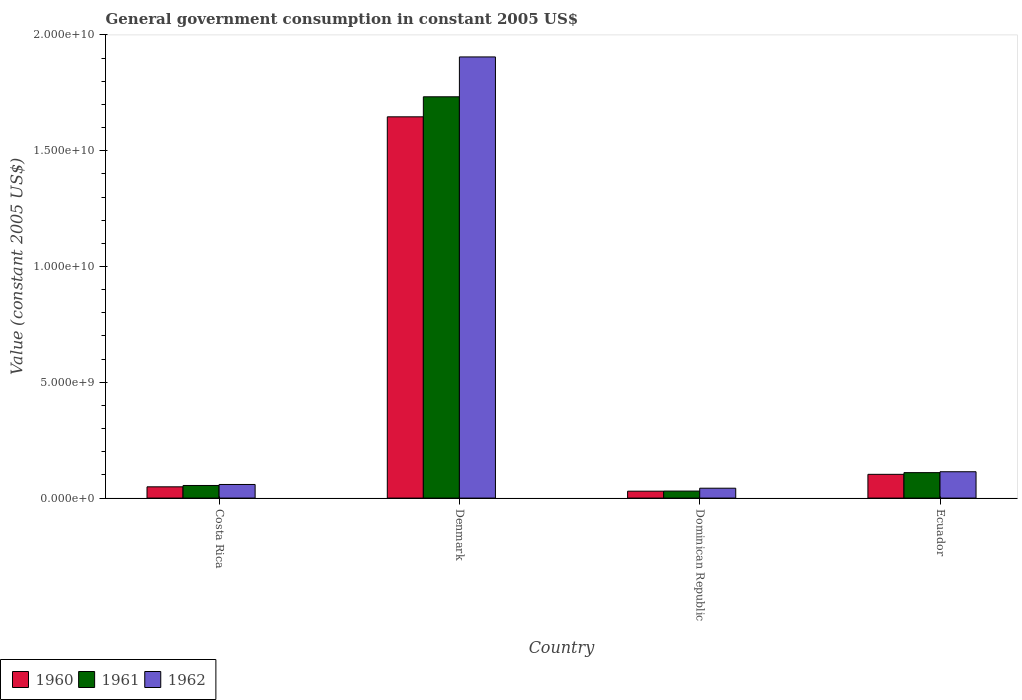How many groups of bars are there?
Offer a terse response. 4. Are the number of bars per tick equal to the number of legend labels?
Your response must be concise. Yes. How many bars are there on the 1st tick from the right?
Offer a very short reply. 3. What is the government conusmption in 1962 in Dominican Republic?
Your answer should be compact. 4.27e+08. Across all countries, what is the maximum government conusmption in 1961?
Provide a short and direct response. 1.73e+1. Across all countries, what is the minimum government conusmption in 1961?
Keep it short and to the point. 3.03e+08. In which country was the government conusmption in 1962 minimum?
Keep it short and to the point. Dominican Republic. What is the total government conusmption in 1960 in the graph?
Your answer should be compact. 1.83e+1. What is the difference between the government conusmption in 1962 in Costa Rica and that in Ecuador?
Your response must be concise. -5.50e+08. What is the difference between the government conusmption in 1961 in Costa Rica and the government conusmption in 1962 in Dominican Republic?
Provide a succinct answer. 1.18e+08. What is the average government conusmption in 1960 per country?
Keep it short and to the point. 4.57e+09. What is the difference between the government conusmption of/in 1960 and government conusmption of/in 1961 in Costa Rica?
Provide a succinct answer. -5.79e+07. What is the ratio of the government conusmption in 1962 in Denmark to that in Ecuador?
Your answer should be compact. 16.74. Is the difference between the government conusmption in 1960 in Dominican Republic and Ecuador greater than the difference between the government conusmption in 1961 in Dominican Republic and Ecuador?
Ensure brevity in your answer.  Yes. What is the difference between the highest and the second highest government conusmption in 1962?
Ensure brevity in your answer.  -5.50e+08. What is the difference between the highest and the lowest government conusmption in 1960?
Ensure brevity in your answer.  1.62e+1. Is the sum of the government conusmption in 1961 in Costa Rica and Dominican Republic greater than the maximum government conusmption in 1962 across all countries?
Offer a very short reply. No. What does the 3rd bar from the left in Ecuador represents?
Provide a short and direct response. 1962. Is it the case that in every country, the sum of the government conusmption in 1962 and government conusmption in 1961 is greater than the government conusmption in 1960?
Ensure brevity in your answer.  Yes. Are all the bars in the graph horizontal?
Your response must be concise. No. Where does the legend appear in the graph?
Offer a terse response. Bottom left. How many legend labels are there?
Your response must be concise. 3. What is the title of the graph?
Provide a succinct answer. General government consumption in constant 2005 US$. Does "1972" appear as one of the legend labels in the graph?
Give a very brief answer. No. What is the label or title of the Y-axis?
Offer a terse response. Value (constant 2005 US$). What is the Value (constant 2005 US$) in 1960 in Costa Rica?
Your response must be concise. 4.87e+08. What is the Value (constant 2005 US$) of 1961 in Costa Rica?
Your answer should be compact. 5.45e+08. What is the Value (constant 2005 US$) of 1962 in Costa Rica?
Offer a terse response. 5.88e+08. What is the Value (constant 2005 US$) in 1960 in Denmark?
Your answer should be compact. 1.65e+1. What is the Value (constant 2005 US$) of 1961 in Denmark?
Your response must be concise. 1.73e+1. What is the Value (constant 2005 US$) in 1962 in Denmark?
Give a very brief answer. 1.91e+1. What is the Value (constant 2005 US$) in 1960 in Dominican Republic?
Give a very brief answer. 2.99e+08. What is the Value (constant 2005 US$) in 1961 in Dominican Republic?
Offer a terse response. 3.03e+08. What is the Value (constant 2005 US$) in 1962 in Dominican Republic?
Offer a very short reply. 4.27e+08. What is the Value (constant 2005 US$) of 1960 in Ecuador?
Ensure brevity in your answer.  1.03e+09. What is the Value (constant 2005 US$) of 1961 in Ecuador?
Give a very brief answer. 1.10e+09. What is the Value (constant 2005 US$) of 1962 in Ecuador?
Give a very brief answer. 1.14e+09. Across all countries, what is the maximum Value (constant 2005 US$) in 1960?
Ensure brevity in your answer.  1.65e+1. Across all countries, what is the maximum Value (constant 2005 US$) in 1961?
Give a very brief answer. 1.73e+1. Across all countries, what is the maximum Value (constant 2005 US$) of 1962?
Ensure brevity in your answer.  1.91e+1. Across all countries, what is the minimum Value (constant 2005 US$) of 1960?
Offer a very short reply. 2.99e+08. Across all countries, what is the minimum Value (constant 2005 US$) in 1961?
Ensure brevity in your answer.  3.03e+08. Across all countries, what is the minimum Value (constant 2005 US$) in 1962?
Your answer should be compact. 4.27e+08. What is the total Value (constant 2005 US$) of 1960 in the graph?
Offer a terse response. 1.83e+1. What is the total Value (constant 2005 US$) in 1961 in the graph?
Your answer should be compact. 1.93e+1. What is the total Value (constant 2005 US$) in 1962 in the graph?
Your answer should be compact. 2.12e+1. What is the difference between the Value (constant 2005 US$) in 1960 in Costa Rica and that in Denmark?
Provide a succinct answer. -1.60e+1. What is the difference between the Value (constant 2005 US$) in 1961 in Costa Rica and that in Denmark?
Your answer should be very brief. -1.68e+1. What is the difference between the Value (constant 2005 US$) of 1962 in Costa Rica and that in Denmark?
Make the answer very short. -1.85e+1. What is the difference between the Value (constant 2005 US$) in 1960 in Costa Rica and that in Dominican Republic?
Provide a succinct answer. 1.88e+08. What is the difference between the Value (constant 2005 US$) in 1961 in Costa Rica and that in Dominican Republic?
Ensure brevity in your answer.  2.41e+08. What is the difference between the Value (constant 2005 US$) in 1962 in Costa Rica and that in Dominican Republic?
Your answer should be compact. 1.61e+08. What is the difference between the Value (constant 2005 US$) in 1960 in Costa Rica and that in Ecuador?
Provide a succinct answer. -5.39e+08. What is the difference between the Value (constant 2005 US$) in 1961 in Costa Rica and that in Ecuador?
Offer a terse response. -5.55e+08. What is the difference between the Value (constant 2005 US$) in 1962 in Costa Rica and that in Ecuador?
Your answer should be compact. -5.50e+08. What is the difference between the Value (constant 2005 US$) in 1960 in Denmark and that in Dominican Republic?
Provide a short and direct response. 1.62e+1. What is the difference between the Value (constant 2005 US$) in 1961 in Denmark and that in Dominican Republic?
Make the answer very short. 1.70e+1. What is the difference between the Value (constant 2005 US$) in 1962 in Denmark and that in Dominican Republic?
Keep it short and to the point. 1.86e+1. What is the difference between the Value (constant 2005 US$) in 1960 in Denmark and that in Ecuador?
Give a very brief answer. 1.54e+1. What is the difference between the Value (constant 2005 US$) in 1961 in Denmark and that in Ecuador?
Offer a terse response. 1.62e+1. What is the difference between the Value (constant 2005 US$) in 1962 in Denmark and that in Ecuador?
Provide a succinct answer. 1.79e+1. What is the difference between the Value (constant 2005 US$) of 1960 in Dominican Republic and that in Ecuador?
Make the answer very short. -7.27e+08. What is the difference between the Value (constant 2005 US$) of 1961 in Dominican Republic and that in Ecuador?
Offer a very short reply. -7.96e+08. What is the difference between the Value (constant 2005 US$) of 1962 in Dominican Republic and that in Ecuador?
Keep it short and to the point. -7.11e+08. What is the difference between the Value (constant 2005 US$) of 1960 in Costa Rica and the Value (constant 2005 US$) of 1961 in Denmark?
Make the answer very short. -1.68e+1. What is the difference between the Value (constant 2005 US$) of 1960 in Costa Rica and the Value (constant 2005 US$) of 1962 in Denmark?
Provide a succinct answer. -1.86e+1. What is the difference between the Value (constant 2005 US$) in 1961 in Costa Rica and the Value (constant 2005 US$) in 1962 in Denmark?
Keep it short and to the point. -1.85e+1. What is the difference between the Value (constant 2005 US$) of 1960 in Costa Rica and the Value (constant 2005 US$) of 1961 in Dominican Republic?
Provide a short and direct response. 1.83e+08. What is the difference between the Value (constant 2005 US$) of 1960 in Costa Rica and the Value (constant 2005 US$) of 1962 in Dominican Republic?
Your response must be concise. 6.01e+07. What is the difference between the Value (constant 2005 US$) in 1961 in Costa Rica and the Value (constant 2005 US$) in 1962 in Dominican Republic?
Provide a short and direct response. 1.18e+08. What is the difference between the Value (constant 2005 US$) in 1960 in Costa Rica and the Value (constant 2005 US$) in 1961 in Ecuador?
Offer a terse response. -6.13e+08. What is the difference between the Value (constant 2005 US$) of 1960 in Costa Rica and the Value (constant 2005 US$) of 1962 in Ecuador?
Your answer should be compact. -6.51e+08. What is the difference between the Value (constant 2005 US$) of 1961 in Costa Rica and the Value (constant 2005 US$) of 1962 in Ecuador?
Keep it short and to the point. -5.93e+08. What is the difference between the Value (constant 2005 US$) in 1960 in Denmark and the Value (constant 2005 US$) in 1961 in Dominican Republic?
Make the answer very short. 1.62e+1. What is the difference between the Value (constant 2005 US$) in 1960 in Denmark and the Value (constant 2005 US$) in 1962 in Dominican Republic?
Keep it short and to the point. 1.60e+1. What is the difference between the Value (constant 2005 US$) in 1961 in Denmark and the Value (constant 2005 US$) in 1962 in Dominican Republic?
Your answer should be compact. 1.69e+1. What is the difference between the Value (constant 2005 US$) in 1960 in Denmark and the Value (constant 2005 US$) in 1961 in Ecuador?
Keep it short and to the point. 1.54e+1. What is the difference between the Value (constant 2005 US$) of 1960 in Denmark and the Value (constant 2005 US$) of 1962 in Ecuador?
Ensure brevity in your answer.  1.53e+1. What is the difference between the Value (constant 2005 US$) of 1961 in Denmark and the Value (constant 2005 US$) of 1962 in Ecuador?
Provide a short and direct response. 1.62e+1. What is the difference between the Value (constant 2005 US$) in 1960 in Dominican Republic and the Value (constant 2005 US$) in 1961 in Ecuador?
Keep it short and to the point. -8.01e+08. What is the difference between the Value (constant 2005 US$) of 1960 in Dominican Republic and the Value (constant 2005 US$) of 1962 in Ecuador?
Offer a very short reply. -8.39e+08. What is the difference between the Value (constant 2005 US$) in 1961 in Dominican Republic and the Value (constant 2005 US$) in 1962 in Ecuador?
Offer a very short reply. -8.35e+08. What is the average Value (constant 2005 US$) in 1960 per country?
Provide a short and direct response. 4.57e+09. What is the average Value (constant 2005 US$) of 1961 per country?
Your answer should be very brief. 4.82e+09. What is the average Value (constant 2005 US$) in 1962 per country?
Give a very brief answer. 5.30e+09. What is the difference between the Value (constant 2005 US$) in 1960 and Value (constant 2005 US$) in 1961 in Costa Rica?
Make the answer very short. -5.79e+07. What is the difference between the Value (constant 2005 US$) in 1960 and Value (constant 2005 US$) in 1962 in Costa Rica?
Give a very brief answer. -1.01e+08. What is the difference between the Value (constant 2005 US$) in 1961 and Value (constant 2005 US$) in 1962 in Costa Rica?
Your answer should be compact. -4.32e+07. What is the difference between the Value (constant 2005 US$) in 1960 and Value (constant 2005 US$) in 1961 in Denmark?
Your answer should be very brief. -8.65e+08. What is the difference between the Value (constant 2005 US$) in 1960 and Value (constant 2005 US$) in 1962 in Denmark?
Make the answer very short. -2.59e+09. What is the difference between the Value (constant 2005 US$) in 1961 and Value (constant 2005 US$) in 1962 in Denmark?
Ensure brevity in your answer.  -1.72e+09. What is the difference between the Value (constant 2005 US$) of 1960 and Value (constant 2005 US$) of 1961 in Dominican Republic?
Make the answer very short. -4.75e+06. What is the difference between the Value (constant 2005 US$) in 1960 and Value (constant 2005 US$) in 1962 in Dominican Republic?
Give a very brief answer. -1.28e+08. What is the difference between the Value (constant 2005 US$) of 1961 and Value (constant 2005 US$) of 1962 in Dominican Republic?
Ensure brevity in your answer.  -1.23e+08. What is the difference between the Value (constant 2005 US$) in 1960 and Value (constant 2005 US$) in 1961 in Ecuador?
Ensure brevity in your answer.  -7.35e+07. What is the difference between the Value (constant 2005 US$) of 1960 and Value (constant 2005 US$) of 1962 in Ecuador?
Offer a very short reply. -1.12e+08. What is the difference between the Value (constant 2005 US$) in 1961 and Value (constant 2005 US$) in 1962 in Ecuador?
Give a very brief answer. -3.85e+07. What is the ratio of the Value (constant 2005 US$) in 1960 in Costa Rica to that in Denmark?
Keep it short and to the point. 0.03. What is the ratio of the Value (constant 2005 US$) of 1961 in Costa Rica to that in Denmark?
Make the answer very short. 0.03. What is the ratio of the Value (constant 2005 US$) in 1962 in Costa Rica to that in Denmark?
Ensure brevity in your answer.  0.03. What is the ratio of the Value (constant 2005 US$) of 1960 in Costa Rica to that in Dominican Republic?
Offer a very short reply. 1.63. What is the ratio of the Value (constant 2005 US$) of 1961 in Costa Rica to that in Dominican Republic?
Offer a very short reply. 1.8. What is the ratio of the Value (constant 2005 US$) in 1962 in Costa Rica to that in Dominican Republic?
Provide a succinct answer. 1.38. What is the ratio of the Value (constant 2005 US$) of 1960 in Costa Rica to that in Ecuador?
Provide a succinct answer. 0.47. What is the ratio of the Value (constant 2005 US$) of 1961 in Costa Rica to that in Ecuador?
Give a very brief answer. 0.5. What is the ratio of the Value (constant 2005 US$) of 1962 in Costa Rica to that in Ecuador?
Your answer should be very brief. 0.52. What is the ratio of the Value (constant 2005 US$) of 1960 in Denmark to that in Dominican Republic?
Give a very brief answer. 55.14. What is the ratio of the Value (constant 2005 US$) of 1961 in Denmark to that in Dominican Republic?
Provide a short and direct response. 57.13. What is the ratio of the Value (constant 2005 US$) in 1962 in Denmark to that in Dominican Republic?
Your answer should be compact. 44.66. What is the ratio of the Value (constant 2005 US$) in 1960 in Denmark to that in Ecuador?
Make the answer very short. 16.05. What is the ratio of the Value (constant 2005 US$) in 1961 in Denmark to that in Ecuador?
Your response must be concise. 15.76. What is the ratio of the Value (constant 2005 US$) of 1962 in Denmark to that in Ecuador?
Provide a succinct answer. 16.74. What is the ratio of the Value (constant 2005 US$) of 1960 in Dominican Republic to that in Ecuador?
Your answer should be compact. 0.29. What is the ratio of the Value (constant 2005 US$) of 1961 in Dominican Republic to that in Ecuador?
Offer a very short reply. 0.28. What is the ratio of the Value (constant 2005 US$) of 1962 in Dominican Republic to that in Ecuador?
Ensure brevity in your answer.  0.37. What is the difference between the highest and the second highest Value (constant 2005 US$) of 1960?
Keep it short and to the point. 1.54e+1. What is the difference between the highest and the second highest Value (constant 2005 US$) in 1961?
Your answer should be compact. 1.62e+1. What is the difference between the highest and the second highest Value (constant 2005 US$) in 1962?
Keep it short and to the point. 1.79e+1. What is the difference between the highest and the lowest Value (constant 2005 US$) of 1960?
Keep it short and to the point. 1.62e+1. What is the difference between the highest and the lowest Value (constant 2005 US$) in 1961?
Your answer should be very brief. 1.70e+1. What is the difference between the highest and the lowest Value (constant 2005 US$) in 1962?
Provide a short and direct response. 1.86e+1. 